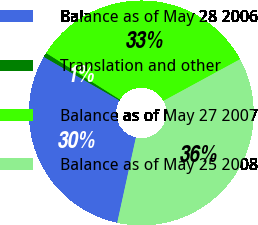<chart> <loc_0><loc_0><loc_500><loc_500><pie_chart><fcel>Balance as of May 28 2006<fcel>Translation and other<fcel>Balance as of May 27 2007<fcel>Balance as of May 25 2008<nl><fcel>29.88%<fcel>0.64%<fcel>33.12%<fcel>36.36%<nl></chart> 